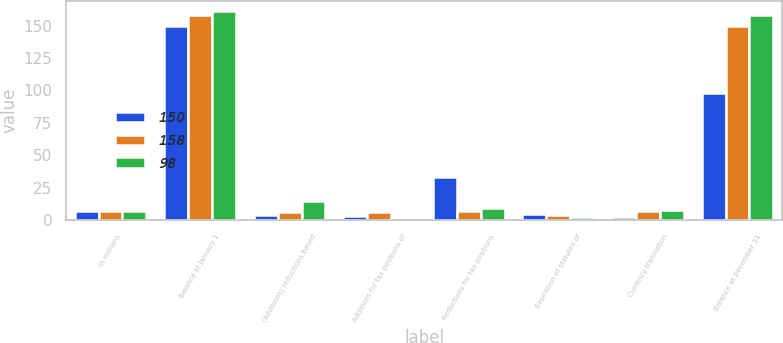<chart> <loc_0><loc_0><loc_500><loc_500><stacked_bar_chart><ecel><fcel>In millions<fcel>Balance at January 1<fcel>(Additions) reductions based<fcel>Additions for tax positions of<fcel>Reductions for tax positions<fcel>Expiration of statutes of<fcel>Currency translation<fcel>Balance at December 31<nl><fcel>150<fcel>7<fcel>150<fcel>4<fcel>3<fcel>33<fcel>5<fcel>2<fcel>98<nl><fcel>158<fcel>7<fcel>158<fcel>6<fcel>6<fcel>7<fcel>4<fcel>7<fcel>150<nl><fcel>98<fcel>7<fcel>161<fcel>15<fcel>1<fcel>9<fcel>2<fcel>8<fcel>158<nl></chart> 